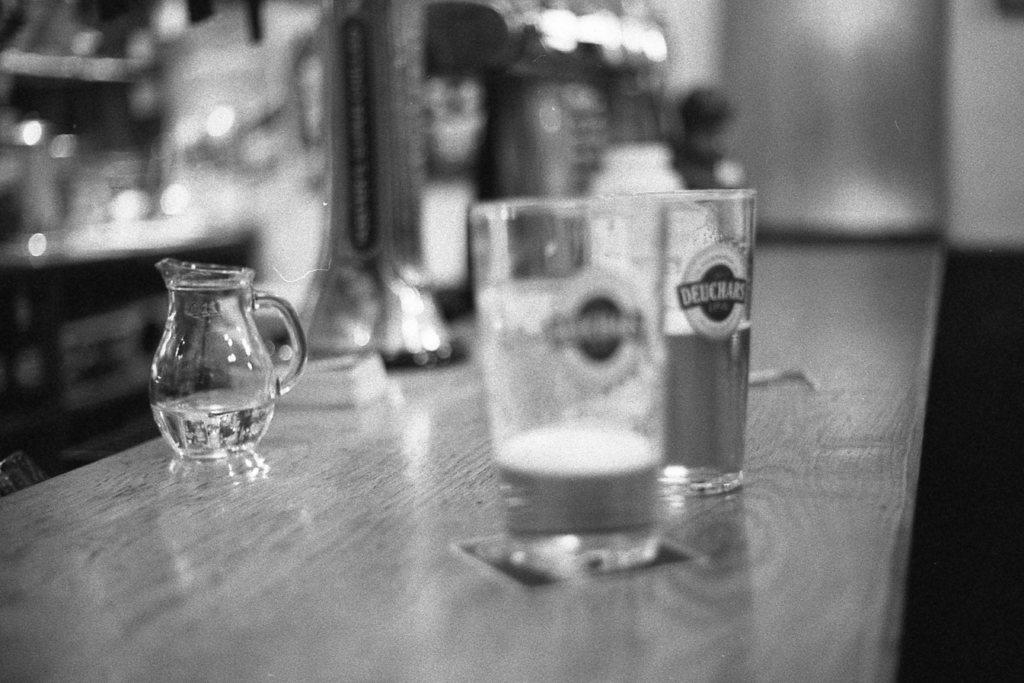What piece of furniture is present in the image? There is a table in the image. What color is the table? The table is white. What objects are placed on the table? There are glasses on the table. How many goldfish are swimming in the glasses on the table? There are no goldfish present in the image; the glasses are empty or contain other items. 